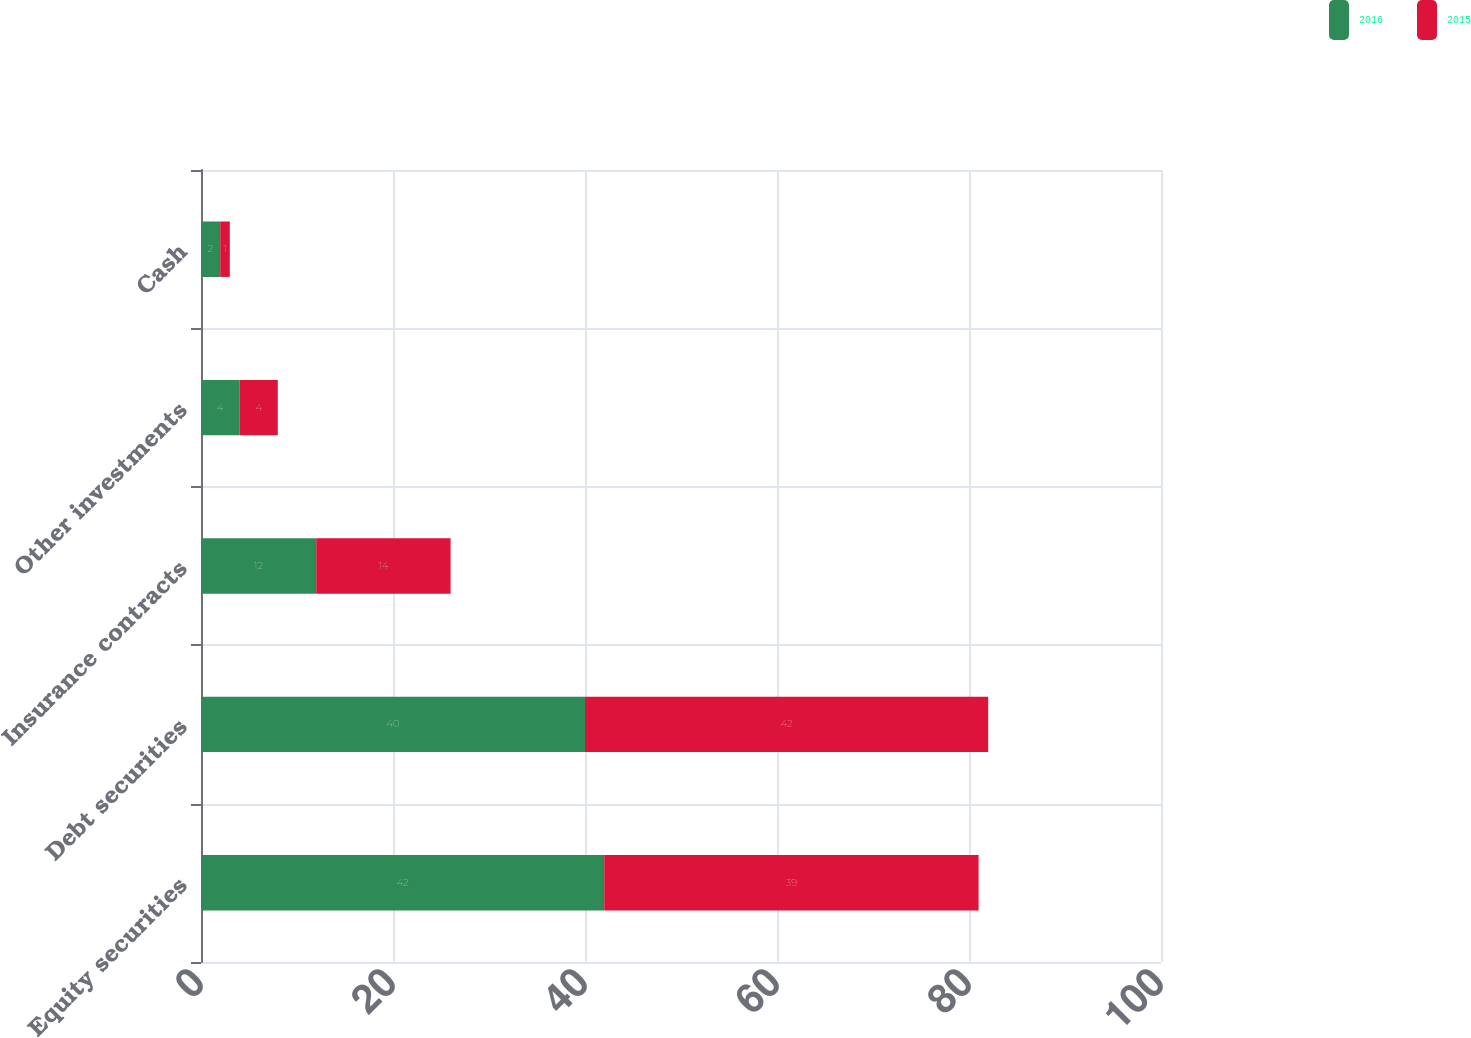<chart> <loc_0><loc_0><loc_500><loc_500><stacked_bar_chart><ecel><fcel>Equity securities<fcel>Debt securities<fcel>Insurance contracts<fcel>Other investments<fcel>Cash<nl><fcel>2016<fcel>42<fcel>40<fcel>12<fcel>4<fcel>2<nl><fcel>2015<fcel>39<fcel>42<fcel>14<fcel>4<fcel>1<nl></chart> 